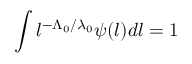<formula> <loc_0><loc_0><loc_500><loc_500>\int l ^ { - \Lambda _ { 0 } / \lambda _ { 0 } } \psi ( l ) d l = 1</formula> 